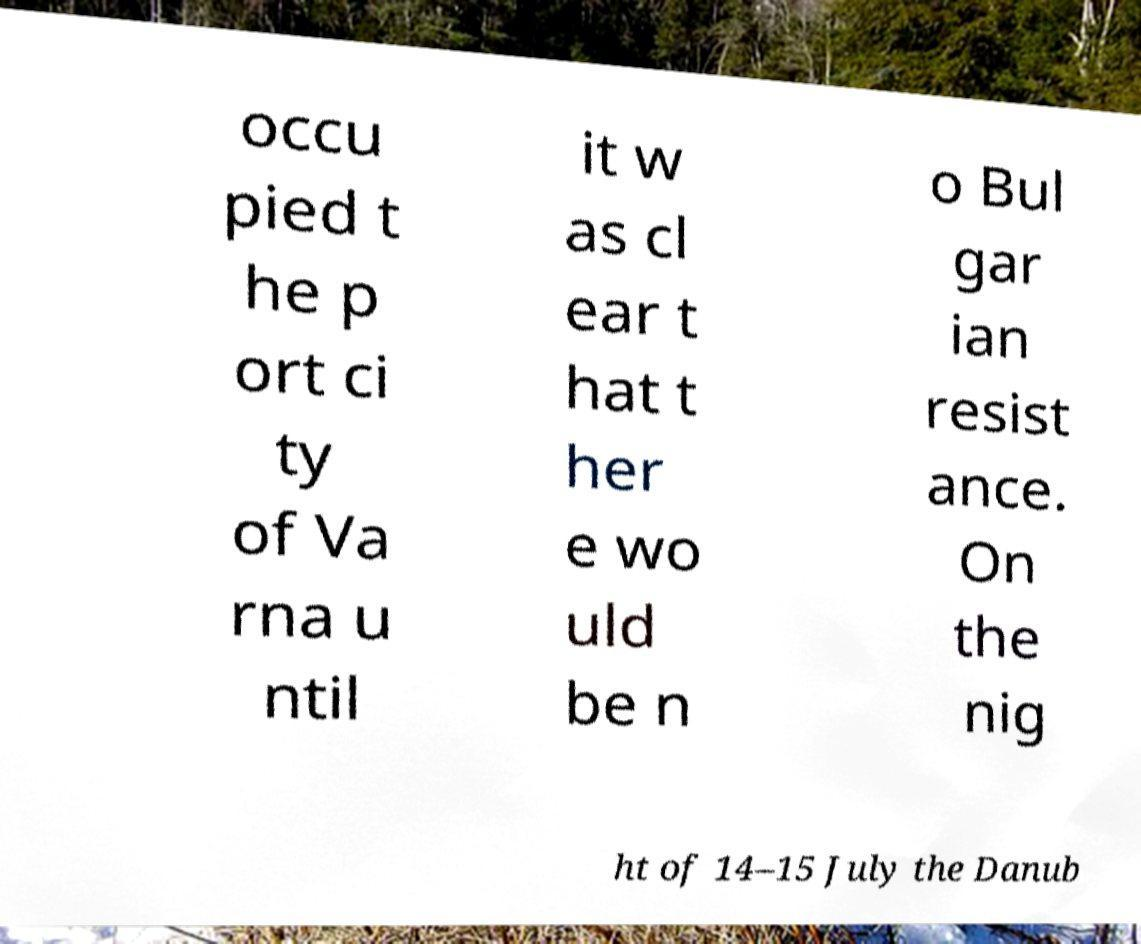Could you assist in decoding the text presented in this image and type it out clearly? occu pied t he p ort ci ty of Va rna u ntil it w as cl ear t hat t her e wo uld be n o Bul gar ian resist ance. On the nig ht of 14–15 July the Danub 